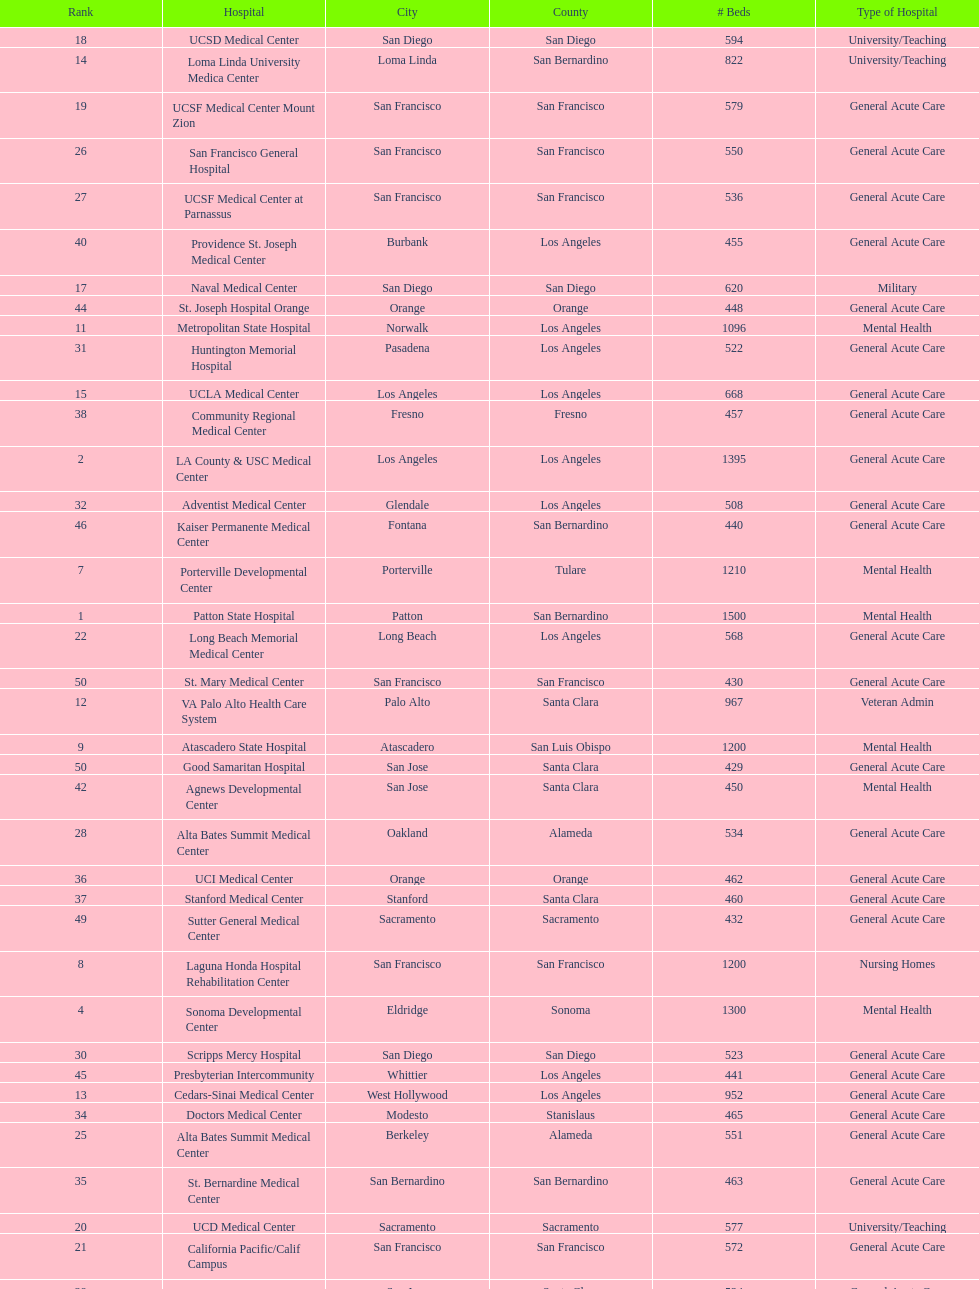What hospital in los angeles county providing hospital beds specifically for rehabilitation is ranked at least among the top 10 hospitals? Lanterman Developmental Center. 